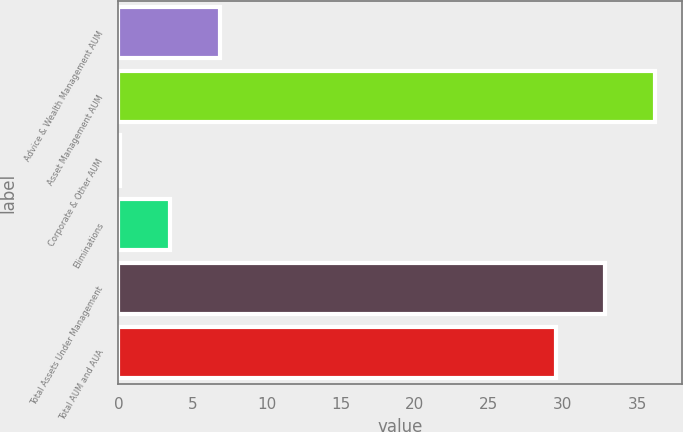<chart> <loc_0><loc_0><loc_500><loc_500><bar_chart><fcel>Advice & Wealth Management AUM<fcel>Asset Management AUM<fcel>Corporate & Other AUM<fcel>Eliminations<fcel>Total Assets Under Management<fcel>Total AUM and AUA<nl><fcel>6.82<fcel>36.22<fcel>0.1<fcel>3.46<fcel>32.86<fcel>29.5<nl></chart> 